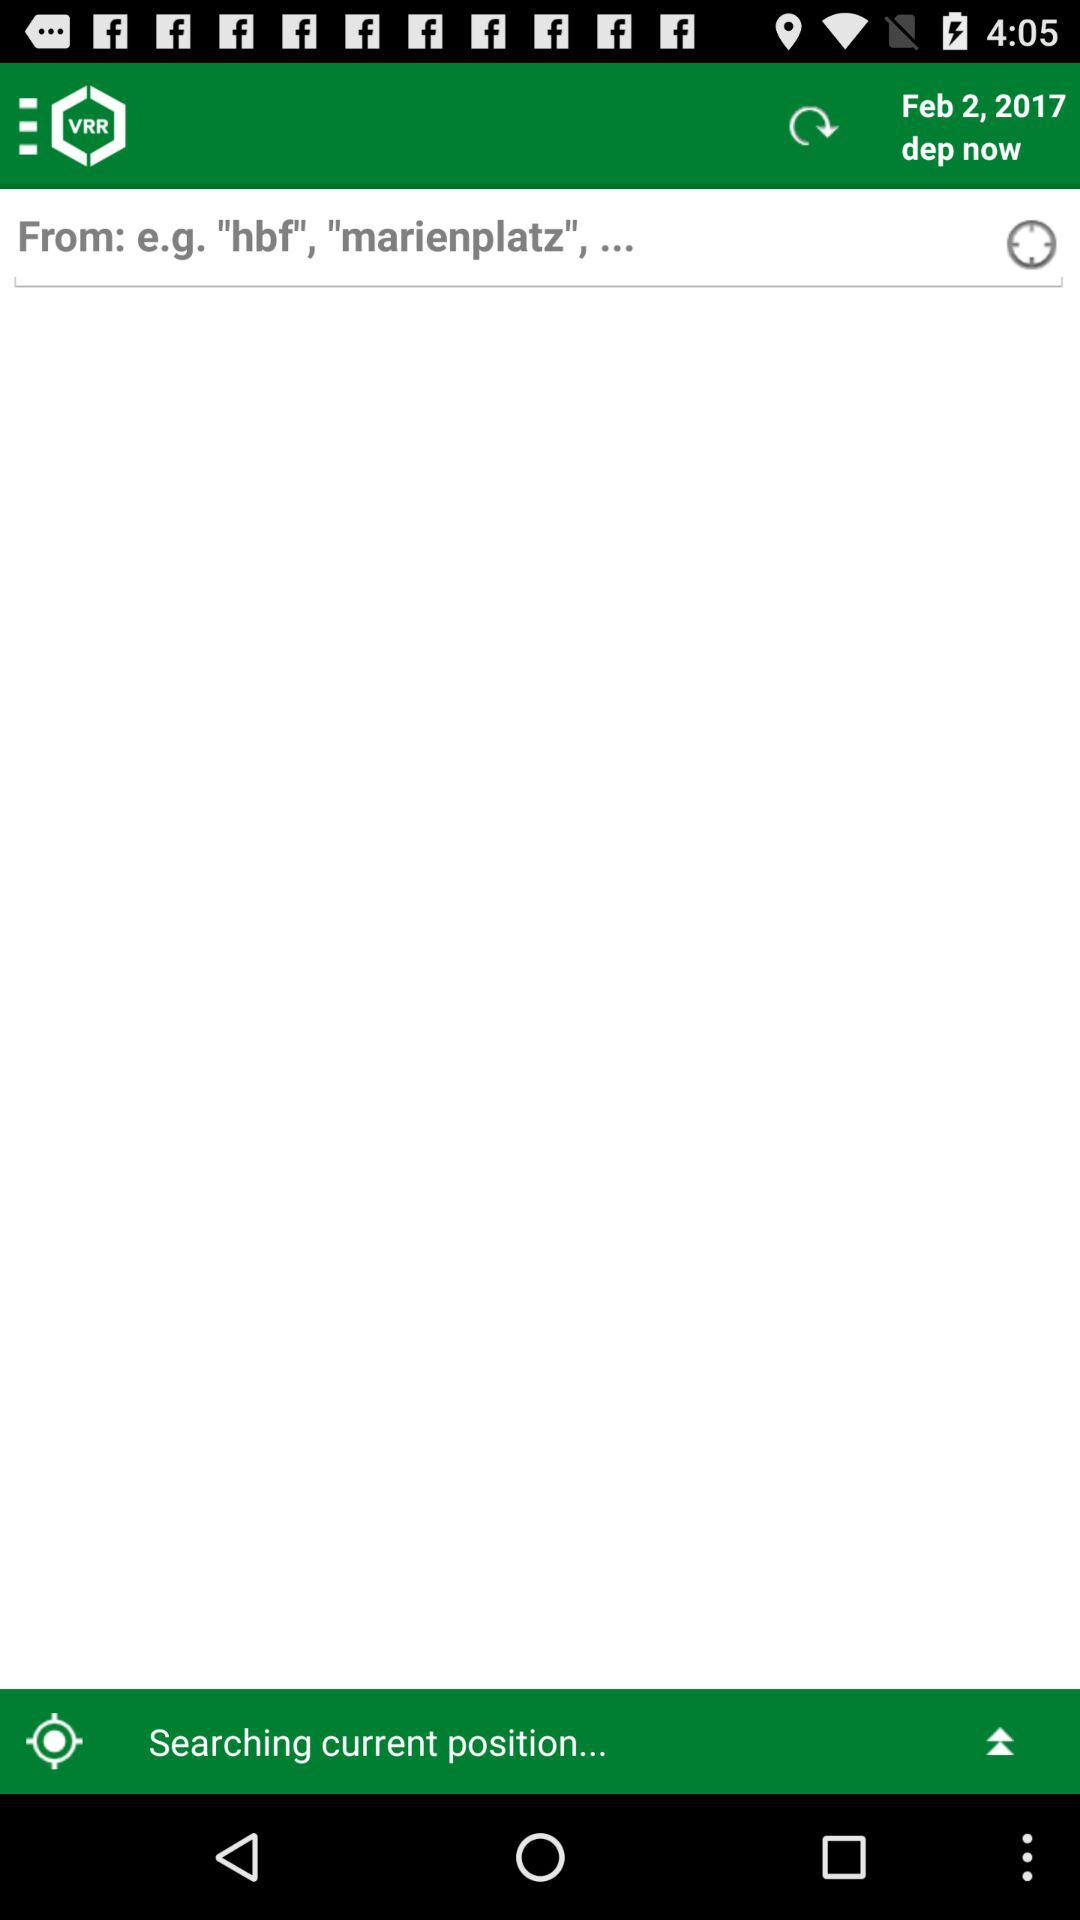What are the examples in "From" field? The examples in "From" field are "hbf" and "marienplatz". 